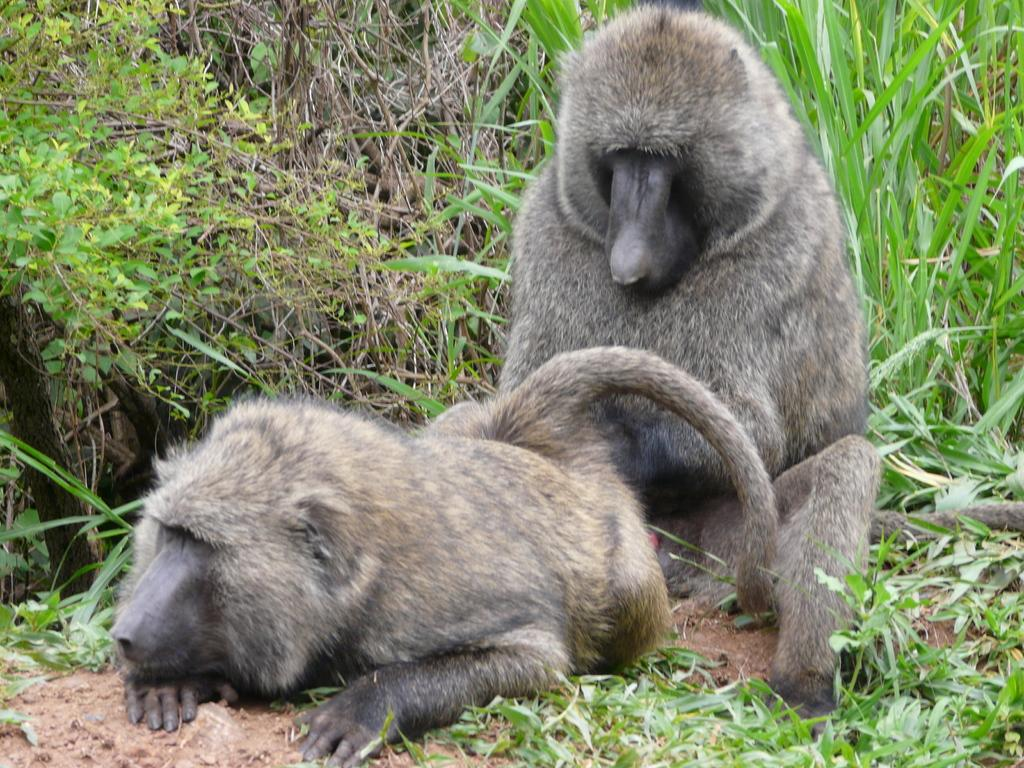How many monkeys are present in the image? There are two monkeys in the image. What type of vegetation can be seen in the image? There are bushes and plants in the image. What is the surface on which the monkeys are standing? There is grass on the surface in the image. What type of sticks are being used for the operation in the image? There is no operation or sticks present in the image. 